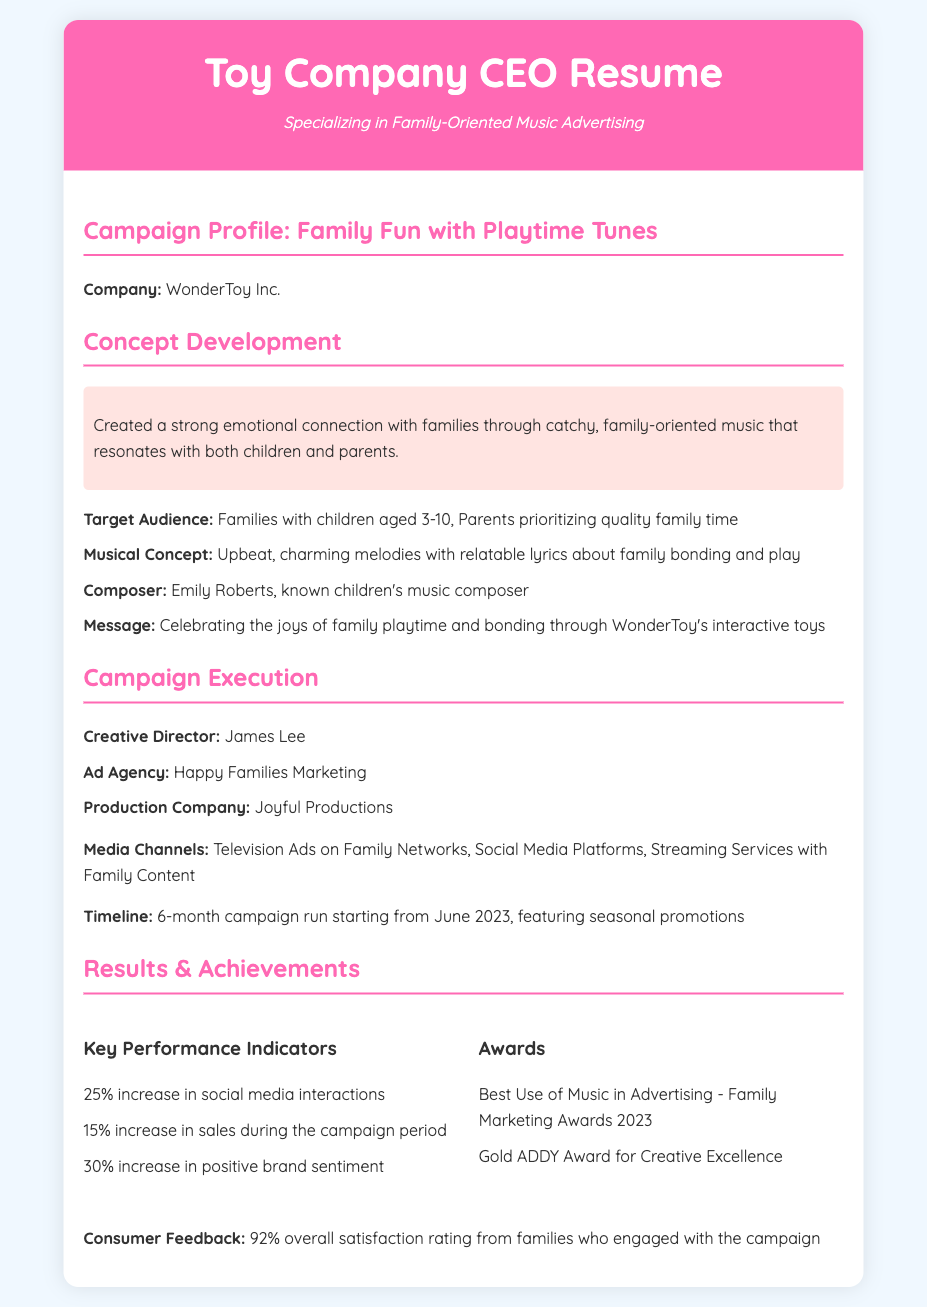What is the title of the campaign? The title of the campaign is found in the header section, indicating the focal theme of the advertising effort.
Answer: Family Fun with Playtime Tunes Who was the composer of the campaign music? The composer is mentioned in the concept development section as a key contributor to the campaign's musical aspect.
Answer: Emily Roberts What was the timeframe for the campaign? The timeline is outlined in the execution section, detailing when the campaign occurred and its duration.
Answer: 6 months What percentage increase in sales was observed during the campaign? This statistic is included in the results section, providing a quantifiable measure of the campaign's financial impact.
Answer: 15% Who was the creative director for the campaign? The name of the creative director is listed in the execution section, indicating their leadership role in the project.
Answer: James Lee What award did the campaign win for music in advertising? The specific recognition received for the use of music is mentioned in the awards subsection of the results section.
Answer: Best Use of Music in Advertising - Family Marketing Awards 2023 What was the overall satisfaction rating from families? This feedback metric is included in the results section, summarizing consumer response to the campaign.
Answer: 92% What was the target audience for the campaign? The demographic focus is provided in the concept development section, highlighting who the campaign aimed to reach.
Answer: Families with children aged 3-10 